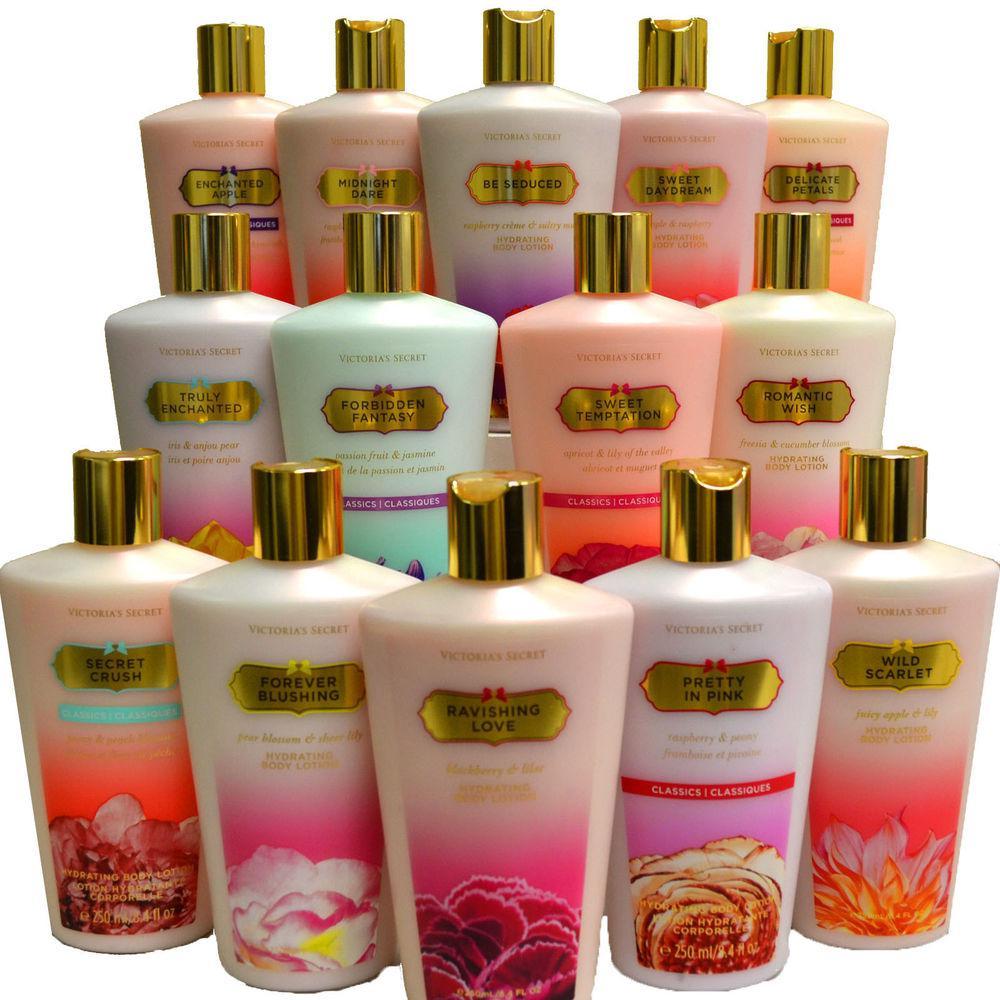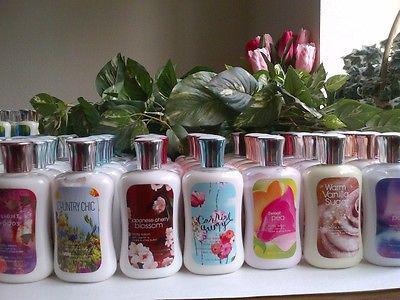The first image is the image on the left, the second image is the image on the right. Assess this claim about the two images: "There are only two bottles in one of the images.". Correct or not? Answer yes or no. No. 